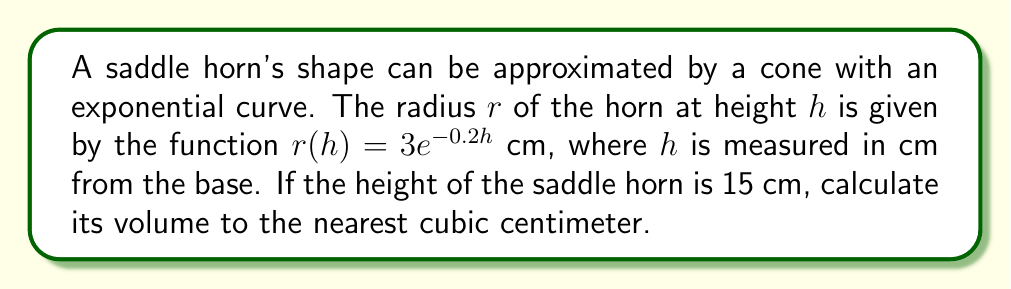What is the answer to this math problem? To calculate the volume of the saddle horn, we need to use the formula for the volume of a solid with a known cross-sectional area. The steps are as follows:

1) The cross-sectional area of the horn at any height $h$ is a circle with radius $r(h) = 3e^{-0.2h}$ cm. The area of this circle is:

   $A(h) = \pi r(h)^2 = \pi (3e^{-0.2h})^2 = 9\pi e^{-0.4h}$ cm²

2) The volume of the horn can be calculated using the integral:

   $V = \int_0^{15} A(h) dh = \int_0^{15} 9\pi e^{-0.4h} dh$

3) To solve this integral:

   $V = 9\pi \int_0^{15} e^{-0.4h} dh = 9\pi [-\frac{1}{0.4}e^{-0.4h}]_0^{15}$

4) Evaluating the integral:

   $V = 9\pi [-\frac{1}{0.4}e^{-0.4(15)} + \frac{1}{0.4}e^{-0.4(0)}]$
   
   $= 9\pi [-\frac{1}{0.4}e^{-6} + \frac{1}{0.4}]$
   
   $= \frac{9\pi}{0.4} [1 - e^{-6}]$

5) Calculating the final result:

   $V \approx 70.69$ cm³

6) Rounding to the nearest cubic centimeter:

   $V \approx 71$ cm³
Answer: 71 cm³ 